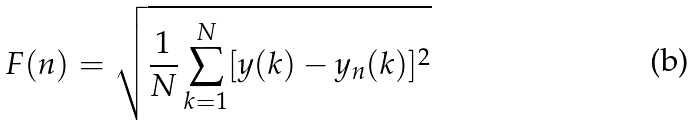Convert formula to latex. <formula><loc_0><loc_0><loc_500><loc_500>F ( n ) = \sqrt { \frac { 1 } { N } \sum _ { k = 1 } ^ { N } [ y ( k ) - y _ { n } ( k ) ] ^ { 2 } }</formula> 